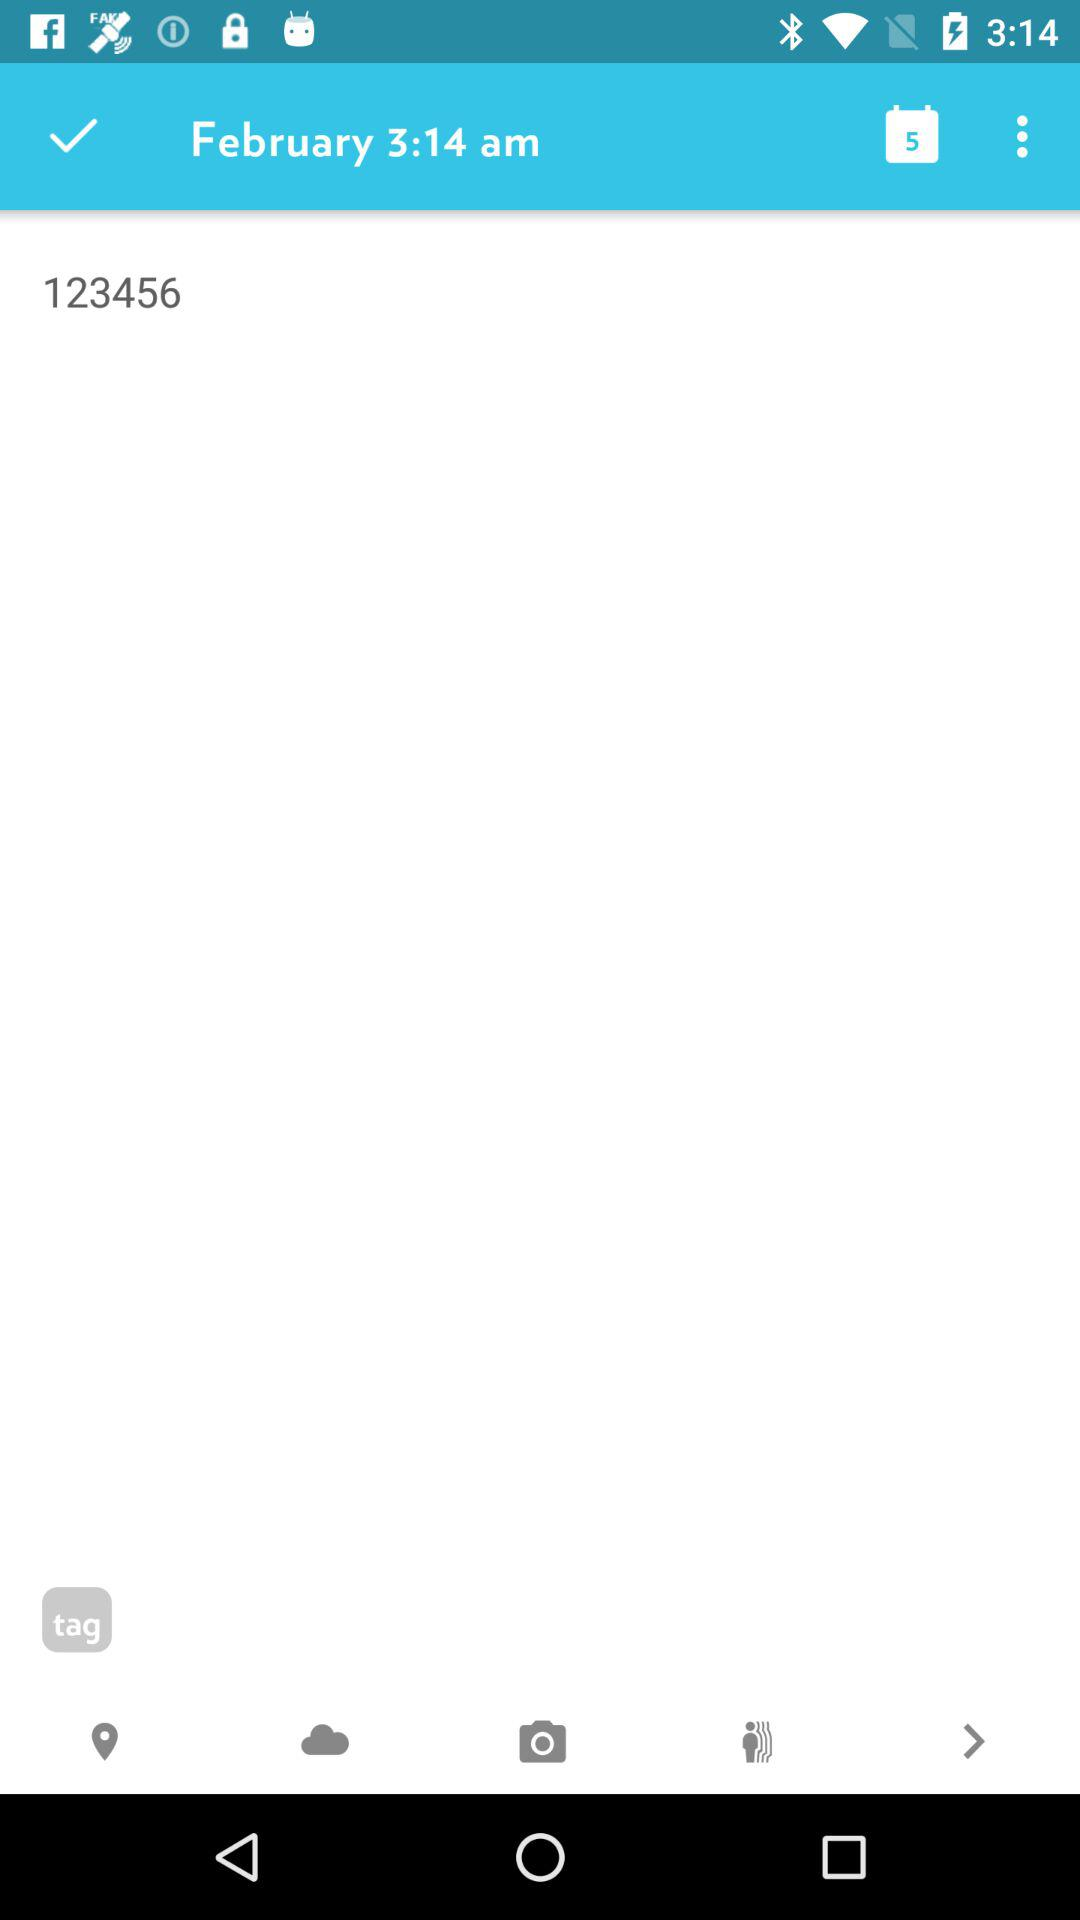What month is mentioned? The mentioned month is "February". 